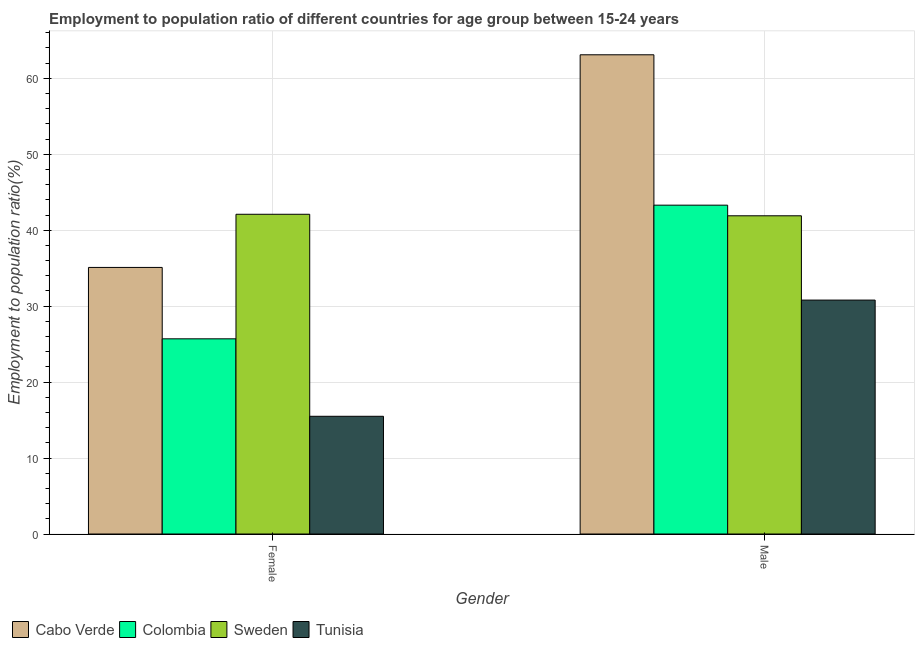How many groups of bars are there?
Keep it short and to the point. 2. Are the number of bars per tick equal to the number of legend labels?
Provide a succinct answer. Yes. Are the number of bars on each tick of the X-axis equal?
Give a very brief answer. Yes. How many bars are there on the 1st tick from the right?
Provide a short and direct response. 4. What is the employment to population ratio(female) in Cabo Verde?
Ensure brevity in your answer.  35.1. Across all countries, what is the maximum employment to population ratio(male)?
Ensure brevity in your answer.  63.1. Across all countries, what is the minimum employment to population ratio(male)?
Provide a short and direct response. 30.8. In which country was the employment to population ratio(female) maximum?
Offer a terse response. Sweden. In which country was the employment to population ratio(male) minimum?
Ensure brevity in your answer.  Tunisia. What is the total employment to population ratio(female) in the graph?
Ensure brevity in your answer.  118.4. What is the difference between the employment to population ratio(female) in Cabo Verde and that in Tunisia?
Your answer should be compact. 19.6. What is the difference between the employment to population ratio(male) in Colombia and the employment to population ratio(female) in Sweden?
Keep it short and to the point. 1.2. What is the average employment to population ratio(male) per country?
Offer a very short reply. 44.77. What is the difference between the employment to population ratio(male) and employment to population ratio(female) in Colombia?
Your response must be concise. 17.6. In how many countries, is the employment to population ratio(male) greater than 14 %?
Give a very brief answer. 4. What is the ratio of the employment to population ratio(female) in Colombia to that in Cabo Verde?
Provide a succinct answer. 0.73. In how many countries, is the employment to population ratio(male) greater than the average employment to population ratio(male) taken over all countries?
Make the answer very short. 1. How many bars are there?
Provide a succinct answer. 8. How many countries are there in the graph?
Provide a succinct answer. 4. What is the difference between two consecutive major ticks on the Y-axis?
Keep it short and to the point. 10. Where does the legend appear in the graph?
Your answer should be very brief. Bottom left. How many legend labels are there?
Your response must be concise. 4. How are the legend labels stacked?
Your answer should be compact. Horizontal. What is the title of the graph?
Your answer should be very brief. Employment to population ratio of different countries for age group between 15-24 years. Does "United States" appear as one of the legend labels in the graph?
Provide a succinct answer. No. What is the label or title of the Y-axis?
Your response must be concise. Employment to population ratio(%). What is the Employment to population ratio(%) in Cabo Verde in Female?
Offer a very short reply. 35.1. What is the Employment to population ratio(%) in Colombia in Female?
Your response must be concise. 25.7. What is the Employment to population ratio(%) in Sweden in Female?
Your response must be concise. 42.1. What is the Employment to population ratio(%) of Cabo Verde in Male?
Your answer should be very brief. 63.1. What is the Employment to population ratio(%) in Colombia in Male?
Provide a succinct answer. 43.3. What is the Employment to population ratio(%) in Sweden in Male?
Offer a terse response. 41.9. What is the Employment to population ratio(%) in Tunisia in Male?
Give a very brief answer. 30.8. Across all Gender, what is the maximum Employment to population ratio(%) in Cabo Verde?
Your response must be concise. 63.1. Across all Gender, what is the maximum Employment to population ratio(%) of Colombia?
Provide a short and direct response. 43.3. Across all Gender, what is the maximum Employment to population ratio(%) of Sweden?
Your answer should be compact. 42.1. Across all Gender, what is the maximum Employment to population ratio(%) of Tunisia?
Provide a short and direct response. 30.8. Across all Gender, what is the minimum Employment to population ratio(%) of Cabo Verde?
Your answer should be very brief. 35.1. Across all Gender, what is the minimum Employment to population ratio(%) of Colombia?
Provide a short and direct response. 25.7. Across all Gender, what is the minimum Employment to population ratio(%) in Sweden?
Ensure brevity in your answer.  41.9. What is the total Employment to population ratio(%) in Cabo Verde in the graph?
Give a very brief answer. 98.2. What is the total Employment to population ratio(%) in Sweden in the graph?
Provide a succinct answer. 84. What is the total Employment to population ratio(%) of Tunisia in the graph?
Keep it short and to the point. 46.3. What is the difference between the Employment to population ratio(%) in Cabo Verde in Female and that in Male?
Ensure brevity in your answer.  -28. What is the difference between the Employment to population ratio(%) in Colombia in Female and that in Male?
Your answer should be compact. -17.6. What is the difference between the Employment to population ratio(%) of Tunisia in Female and that in Male?
Your answer should be compact. -15.3. What is the difference between the Employment to population ratio(%) in Cabo Verde in Female and the Employment to population ratio(%) in Colombia in Male?
Your response must be concise. -8.2. What is the difference between the Employment to population ratio(%) of Cabo Verde in Female and the Employment to population ratio(%) of Sweden in Male?
Provide a short and direct response. -6.8. What is the difference between the Employment to population ratio(%) of Colombia in Female and the Employment to population ratio(%) of Sweden in Male?
Your answer should be very brief. -16.2. What is the difference between the Employment to population ratio(%) of Sweden in Female and the Employment to population ratio(%) of Tunisia in Male?
Your answer should be very brief. 11.3. What is the average Employment to population ratio(%) in Cabo Verde per Gender?
Make the answer very short. 49.1. What is the average Employment to population ratio(%) of Colombia per Gender?
Your response must be concise. 34.5. What is the average Employment to population ratio(%) of Tunisia per Gender?
Give a very brief answer. 23.15. What is the difference between the Employment to population ratio(%) of Cabo Verde and Employment to population ratio(%) of Colombia in Female?
Your answer should be compact. 9.4. What is the difference between the Employment to population ratio(%) in Cabo Verde and Employment to population ratio(%) in Sweden in Female?
Give a very brief answer. -7. What is the difference between the Employment to population ratio(%) in Cabo Verde and Employment to population ratio(%) in Tunisia in Female?
Your answer should be very brief. 19.6. What is the difference between the Employment to population ratio(%) in Colombia and Employment to population ratio(%) in Sweden in Female?
Ensure brevity in your answer.  -16.4. What is the difference between the Employment to population ratio(%) of Sweden and Employment to population ratio(%) of Tunisia in Female?
Your response must be concise. 26.6. What is the difference between the Employment to population ratio(%) of Cabo Verde and Employment to population ratio(%) of Colombia in Male?
Give a very brief answer. 19.8. What is the difference between the Employment to population ratio(%) in Cabo Verde and Employment to population ratio(%) in Sweden in Male?
Keep it short and to the point. 21.2. What is the difference between the Employment to population ratio(%) of Cabo Verde and Employment to population ratio(%) of Tunisia in Male?
Your answer should be very brief. 32.3. What is the difference between the Employment to population ratio(%) of Colombia and Employment to population ratio(%) of Sweden in Male?
Provide a succinct answer. 1.4. What is the ratio of the Employment to population ratio(%) in Cabo Verde in Female to that in Male?
Your response must be concise. 0.56. What is the ratio of the Employment to population ratio(%) of Colombia in Female to that in Male?
Provide a succinct answer. 0.59. What is the ratio of the Employment to population ratio(%) of Tunisia in Female to that in Male?
Your response must be concise. 0.5. What is the difference between the highest and the second highest Employment to population ratio(%) in Cabo Verde?
Offer a very short reply. 28. What is the difference between the highest and the second highest Employment to population ratio(%) in Tunisia?
Your answer should be very brief. 15.3. What is the difference between the highest and the lowest Employment to population ratio(%) in Tunisia?
Your answer should be compact. 15.3. 